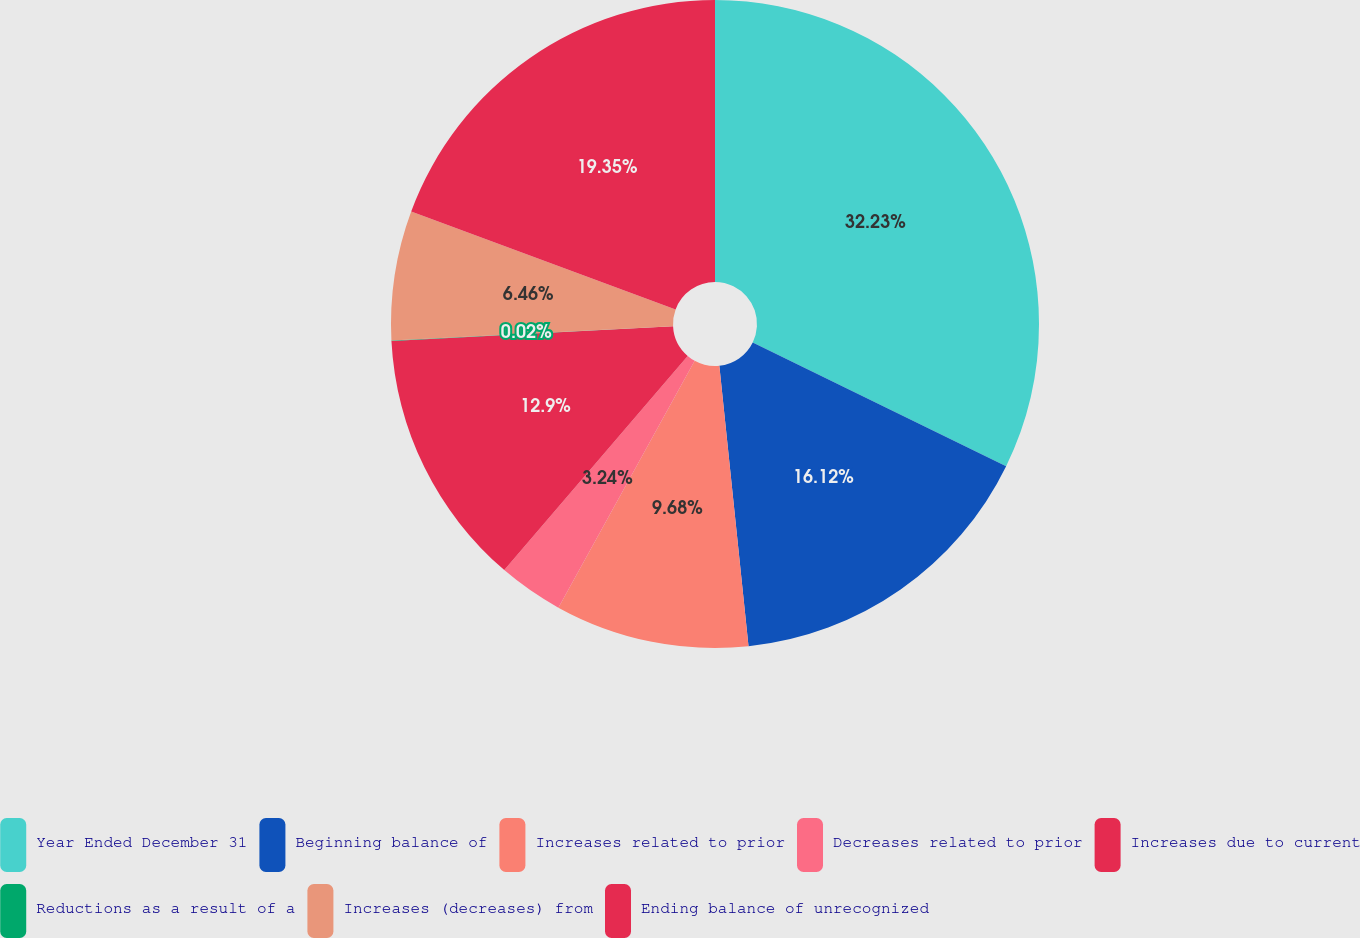Convert chart to OTSL. <chart><loc_0><loc_0><loc_500><loc_500><pie_chart><fcel>Year Ended December 31<fcel>Beginning balance of<fcel>Increases related to prior<fcel>Decreases related to prior<fcel>Increases due to current<fcel>Reductions as a result of a<fcel>Increases (decreases) from<fcel>Ending balance of unrecognized<nl><fcel>32.23%<fcel>16.12%<fcel>9.68%<fcel>3.24%<fcel>12.9%<fcel>0.02%<fcel>6.46%<fcel>19.35%<nl></chart> 